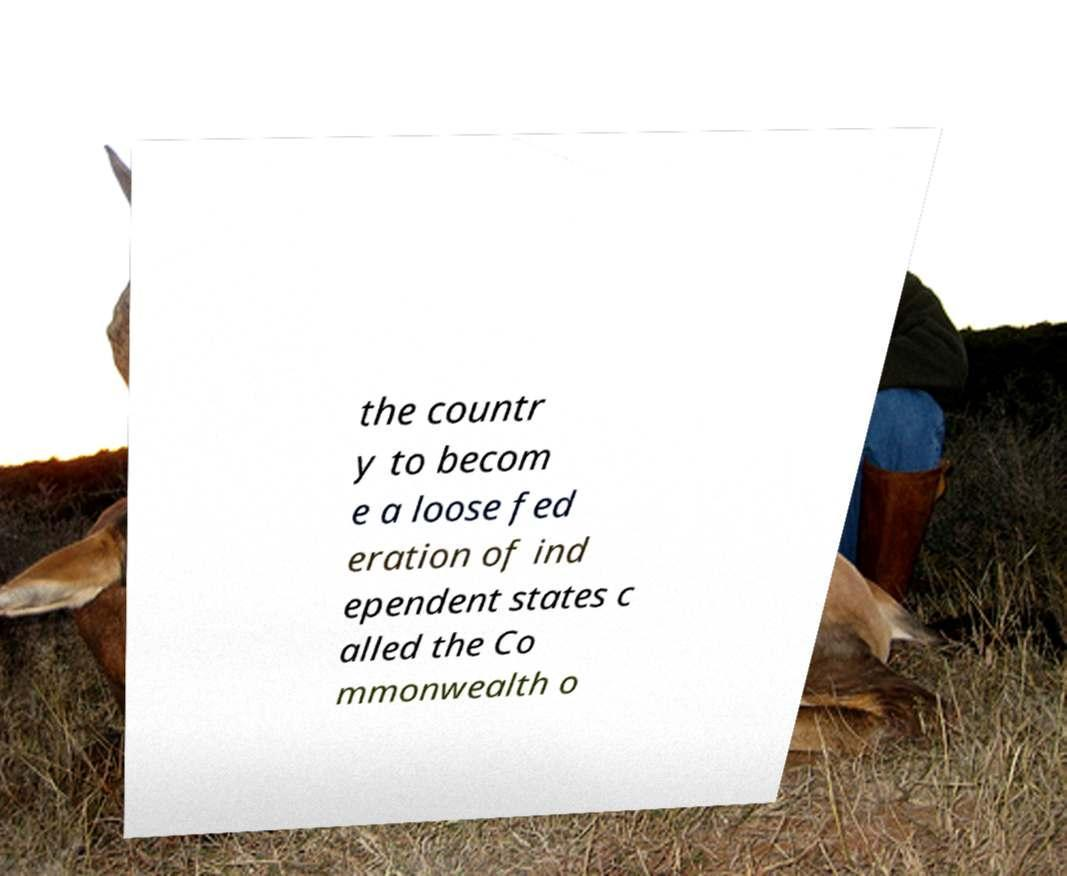Please identify and transcribe the text found in this image. the countr y to becom e a loose fed eration of ind ependent states c alled the Co mmonwealth o 